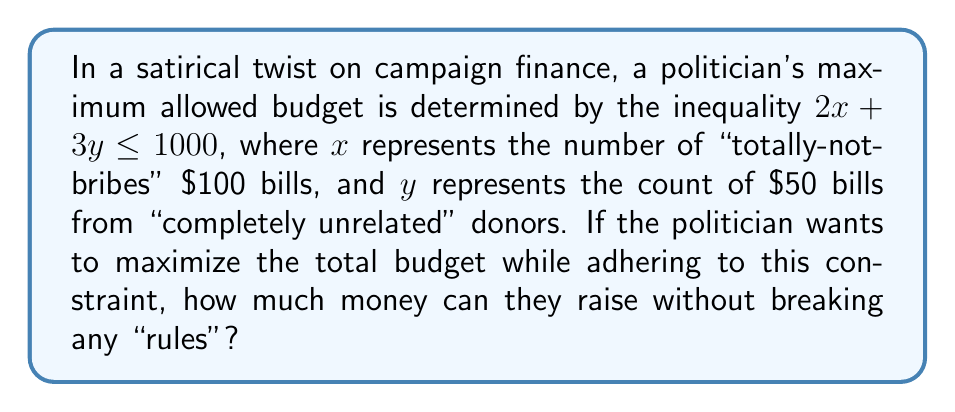Can you solve this math problem? Let's approach this step-by-step:

1) The inequality given is $2x + 3y \leq 1000$, where:
   $x$ = number of $100 bills
   $y$ = number of $50 bills

2) To maximize the total budget, we need to maximize the function:
   $T = 100x + 50y$, where T is the total budget

3) This is a linear programming problem. The maximum will occur at one of the vertices of the feasible region.

4) The vertices are:
   (0, 0), (500, 0), and (0, 333.33...)

5) Let's calculate T for each vertex:
   At (0, 0): $T = 100(0) + 50(0) = 0$
   At (500, 0): $T = 100(500) + 50(0) = 50,000$
   At (0, 333.33...): $T = 100(0) + 50(333.33...) = 16,666.67$

6) The maximum value occurs at (500, 0), which represents 500 $100 bills and 0 $50 bills.

7) Therefore, the maximum budget is $50,000.
Answer: $50,000 